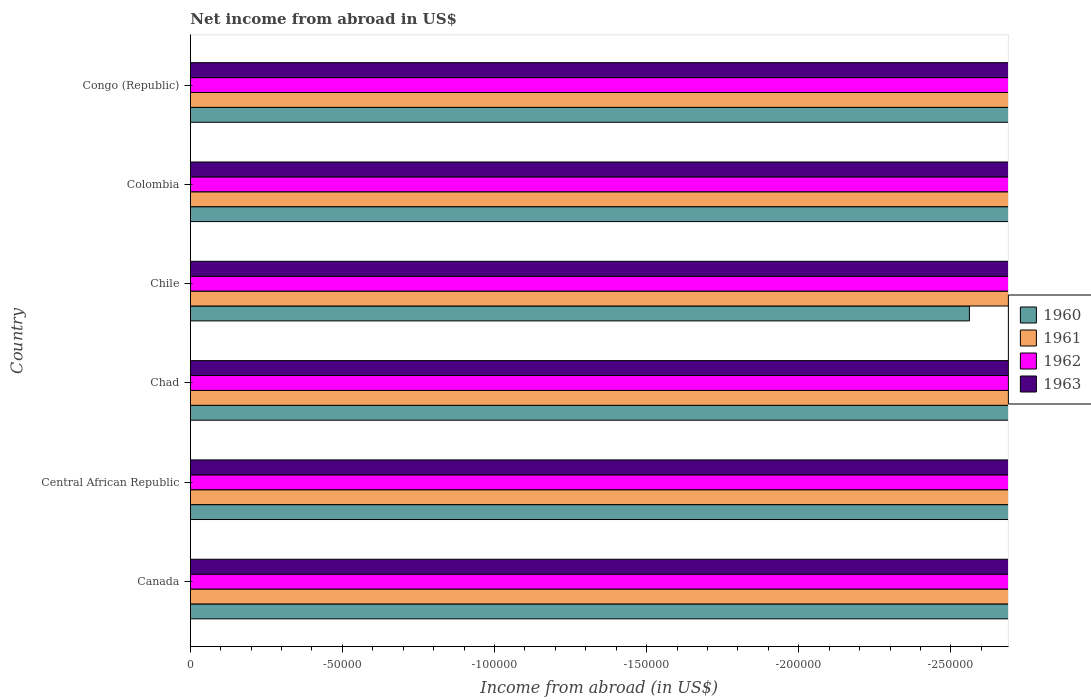Are the number of bars per tick equal to the number of legend labels?
Offer a very short reply. No. How many bars are there on the 3rd tick from the top?
Provide a short and direct response. 0. How many bars are there on the 6th tick from the bottom?
Provide a short and direct response. 0. In how many cases, is the number of bars for a given country not equal to the number of legend labels?
Make the answer very short. 6. What is the net income from abroad in 1961 in Congo (Republic)?
Provide a short and direct response. 0. What is the average net income from abroad in 1961 per country?
Give a very brief answer. 0. In how many countries, is the net income from abroad in 1961 greater than -80000 US$?
Your answer should be very brief. 0. In how many countries, is the net income from abroad in 1963 greater than the average net income from abroad in 1963 taken over all countries?
Offer a very short reply. 0. Is it the case that in every country, the sum of the net income from abroad in 1960 and net income from abroad in 1962 is greater than the net income from abroad in 1961?
Your answer should be compact. No. Are all the bars in the graph horizontal?
Make the answer very short. Yes. How many countries are there in the graph?
Keep it short and to the point. 6. Does the graph contain grids?
Offer a very short reply. No. Where does the legend appear in the graph?
Give a very brief answer. Center right. How are the legend labels stacked?
Ensure brevity in your answer.  Vertical. What is the title of the graph?
Ensure brevity in your answer.  Net income from abroad in US$. Does "1987" appear as one of the legend labels in the graph?
Your response must be concise. No. What is the label or title of the X-axis?
Offer a very short reply. Income from abroad (in US$). What is the Income from abroad (in US$) in 1960 in Canada?
Offer a terse response. 0. What is the Income from abroad (in US$) of 1962 in Canada?
Ensure brevity in your answer.  0. What is the Income from abroad (in US$) of 1963 in Canada?
Offer a terse response. 0. What is the Income from abroad (in US$) of 1962 in Central African Republic?
Your answer should be compact. 0. What is the Income from abroad (in US$) of 1963 in Central African Republic?
Provide a succinct answer. 0. What is the Income from abroad (in US$) in 1961 in Chad?
Your answer should be very brief. 0. What is the Income from abroad (in US$) of 1962 in Chad?
Your response must be concise. 0. What is the Income from abroad (in US$) of 1963 in Chad?
Your answer should be very brief. 0. What is the Income from abroad (in US$) of 1962 in Chile?
Make the answer very short. 0. What is the Income from abroad (in US$) of 1960 in Colombia?
Provide a short and direct response. 0. What is the total Income from abroad (in US$) in 1960 in the graph?
Provide a short and direct response. 0. What is the total Income from abroad (in US$) of 1962 in the graph?
Your response must be concise. 0. What is the total Income from abroad (in US$) in 1963 in the graph?
Offer a terse response. 0. What is the average Income from abroad (in US$) in 1961 per country?
Make the answer very short. 0. What is the average Income from abroad (in US$) of 1963 per country?
Your answer should be compact. 0. 